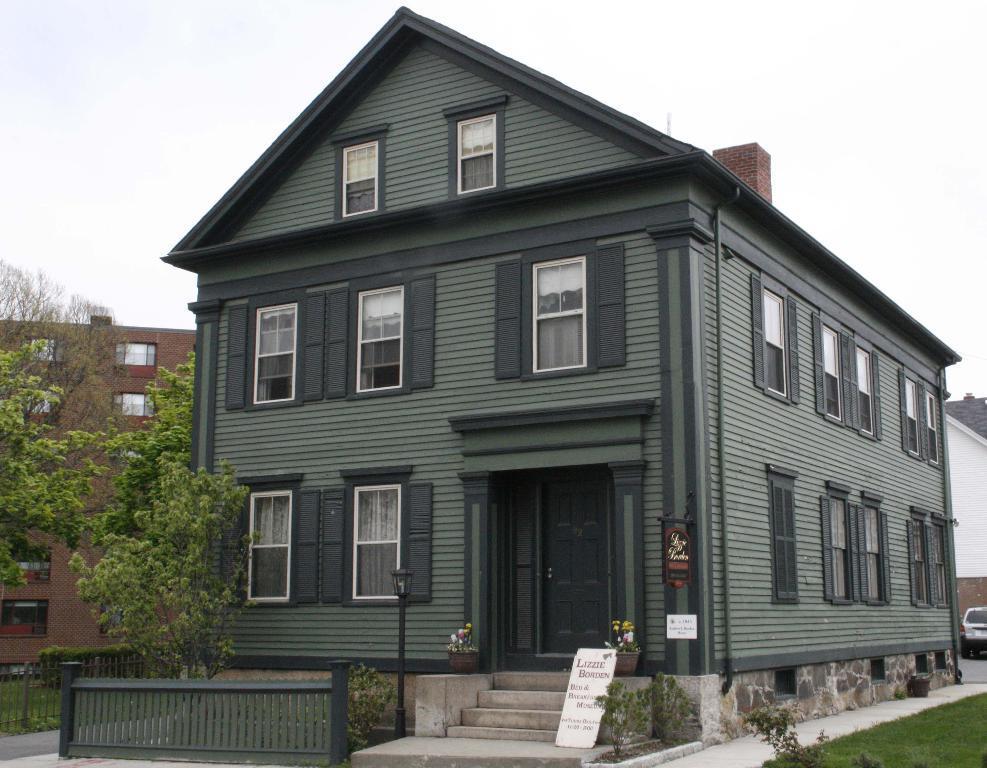Describe this image in one or two sentences. In this image I can see buildings, trees, plants, fence and the grass. In the background I can see the vehicle and the sky. 